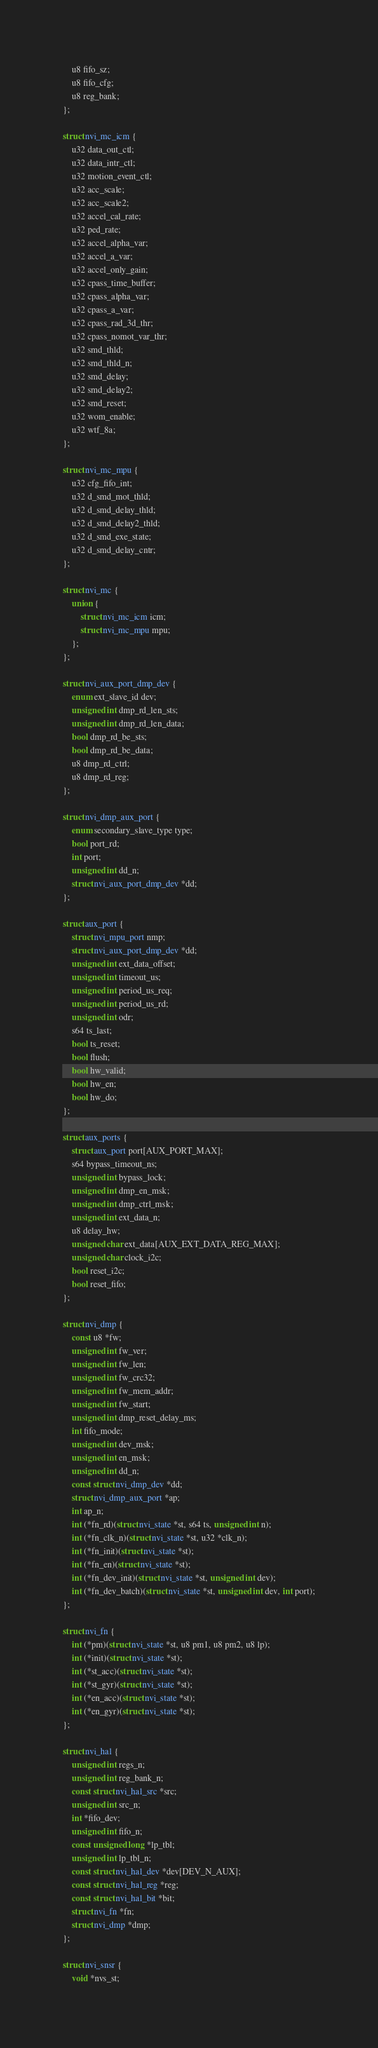<code> <loc_0><loc_0><loc_500><loc_500><_C_>	u8 fifo_sz;
	u8 fifo_cfg;
	u8 reg_bank;
};

struct nvi_mc_icm {
	u32 data_out_ctl;
	u32 data_intr_ctl;
	u32 motion_event_ctl;
	u32 acc_scale;
	u32 acc_scale2;
	u32 accel_cal_rate;
	u32 ped_rate;
	u32 accel_alpha_var;
	u32 accel_a_var;
	u32 accel_only_gain;
	u32 cpass_time_buffer;
	u32 cpass_alpha_var;
	u32 cpass_a_var;
	u32 cpass_rad_3d_thr;
	u32 cpass_nomot_var_thr;
	u32 smd_thld;
	u32 smd_thld_n;
	u32 smd_delay;
	u32 smd_delay2;
	u32 smd_reset;
	u32 wom_enable;
	u32 wtf_8a;
};

struct nvi_mc_mpu {
	u32 cfg_fifo_int;
	u32 d_smd_mot_thld;
	u32 d_smd_delay_thld;
	u32 d_smd_delay2_thld;
	u32 d_smd_exe_state;
	u32 d_smd_delay_cntr;
};

struct nvi_mc {
	union {
		struct nvi_mc_icm icm;
		struct nvi_mc_mpu mpu;
	};
};

struct nvi_aux_port_dmp_dev {
	enum ext_slave_id dev;
	unsigned int dmp_rd_len_sts;
	unsigned int dmp_rd_len_data;
	bool dmp_rd_be_sts;
	bool dmp_rd_be_data;
	u8 dmp_rd_ctrl;
	u8 dmp_rd_reg;
};

struct nvi_dmp_aux_port {
	enum secondary_slave_type type;
	bool port_rd;
	int port;
	unsigned int dd_n;
	struct nvi_aux_port_dmp_dev *dd;
};

struct aux_port {
	struct nvi_mpu_port nmp;
	struct nvi_aux_port_dmp_dev *dd;
	unsigned int ext_data_offset;
	unsigned int timeout_us;
	unsigned int period_us_req;
	unsigned int period_us_rd;
	unsigned int odr;
	s64 ts_last;
	bool ts_reset;
	bool flush;
	bool hw_valid;
	bool hw_en;
	bool hw_do;
};

struct aux_ports {
	struct aux_port port[AUX_PORT_MAX];
	s64 bypass_timeout_ns;
	unsigned int bypass_lock;
	unsigned int dmp_en_msk;
	unsigned int dmp_ctrl_msk;
	unsigned int ext_data_n;
	u8 delay_hw;
	unsigned char ext_data[AUX_EXT_DATA_REG_MAX];
	unsigned char clock_i2c;
	bool reset_i2c;
	bool reset_fifo;
};

struct nvi_dmp {
	const u8 *fw;
	unsigned int fw_ver;
	unsigned int fw_len;
	unsigned int fw_crc32;
	unsigned int fw_mem_addr;
	unsigned int fw_start;
	unsigned int dmp_reset_delay_ms;
	int fifo_mode;
	unsigned int dev_msk;
	unsigned int en_msk;
	unsigned int dd_n;
	const struct nvi_dmp_dev *dd;
	struct nvi_dmp_aux_port *ap;
	int ap_n;
	int (*fn_rd)(struct nvi_state *st, s64 ts, unsigned int n);
	int (*fn_clk_n)(struct nvi_state *st, u32 *clk_n);
	int (*fn_init)(struct nvi_state *st);
	int (*fn_en)(struct nvi_state *st);
	int (*fn_dev_init)(struct nvi_state *st, unsigned int dev);
	int (*fn_dev_batch)(struct nvi_state *st, unsigned int dev, int port);
};

struct nvi_fn {
	int (*pm)(struct nvi_state *st, u8 pm1, u8 pm2, u8 lp);
	int (*init)(struct nvi_state *st);
	int (*st_acc)(struct nvi_state *st);
	int (*st_gyr)(struct nvi_state *st);
	int (*en_acc)(struct nvi_state *st);
	int (*en_gyr)(struct nvi_state *st);
};

struct nvi_hal {
	unsigned int regs_n;
	unsigned int reg_bank_n;
	const struct nvi_hal_src *src;
	unsigned int src_n;
	int *fifo_dev;
	unsigned int fifo_n;
	const unsigned long *lp_tbl;
	unsigned int lp_tbl_n;
	const struct nvi_hal_dev *dev[DEV_N_AUX];
	const struct nvi_hal_reg *reg;
	const struct nvi_hal_bit *bit;
	struct nvi_fn *fn;
	struct nvi_dmp *dmp;
};

struct nvi_snsr {
	void *nvs_st;</code> 